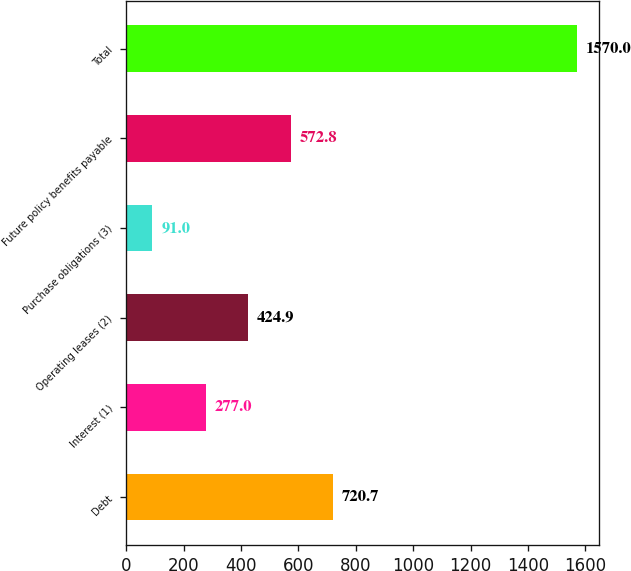<chart> <loc_0><loc_0><loc_500><loc_500><bar_chart><fcel>Debt<fcel>Interest (1)<fcel>Operating leases (2)<fcel>Purchase obligations (3)<fcel>Future policy benefits payable<fcel>Total<nl><fcel>720.7<fcel>277<fcel>424.9<fcel>91<fcel>572.8<fcel>1570<nl></chart> 